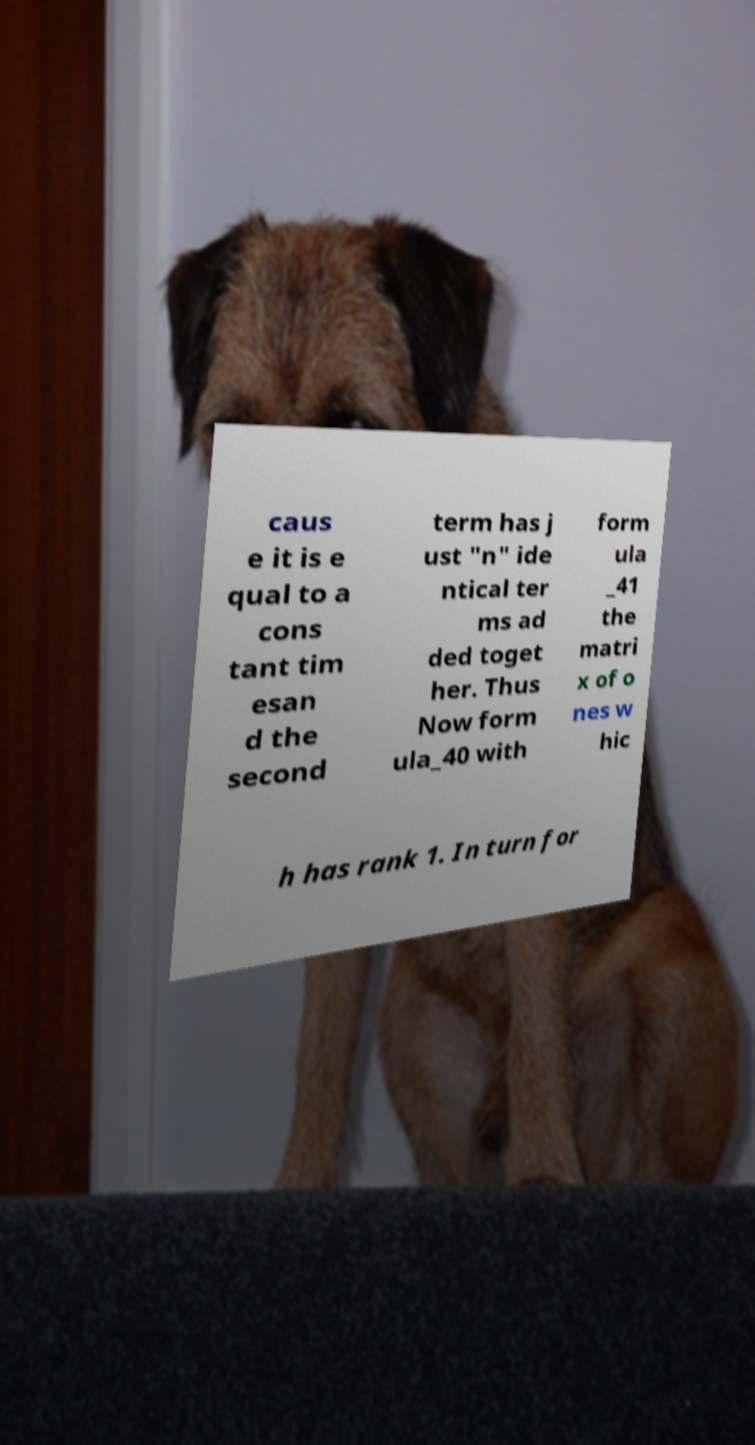Please read and relay the text visible in this image. What does it say? caus e it is e qual to a cons tant tim esan d the second term has j ust "n" ide ntical ter ms ad ded toget her. Thus Now form ula_40 with form ula _41 the matri x of o nes w hic h has rank 1. In turn for 